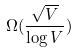Convert formula to latex. <formula><loc_0><loc_0><loc_500><loc_500>\Omega ( \frac { \sqrt { V } } { \log V } )</formula> 